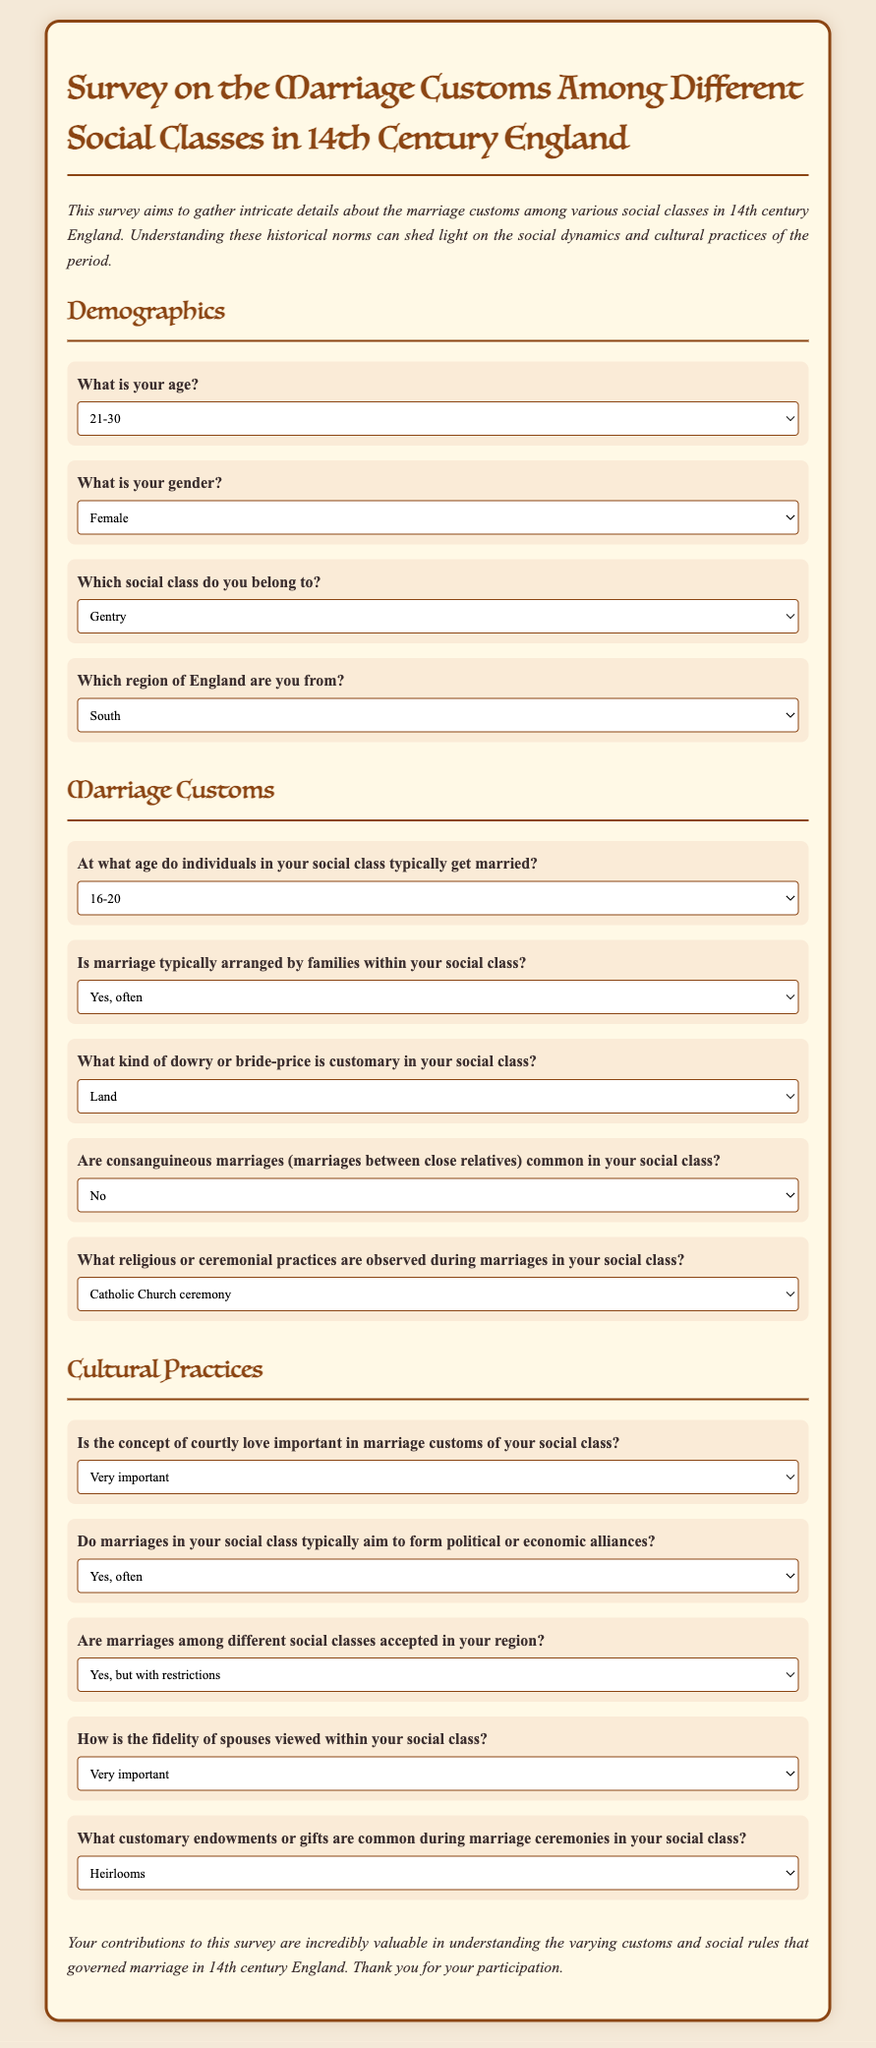What is the age range selected by the participant? The selected age range by the participant in the form is shown in the demographics section, specifically the option selected for age.
Answer: 21-30 What gender did the participant identify as? The participant's gender selection is found under the demographics section, precisely indicating their self-identified gender.
Answer: Female Which social class does the participant belong to? The participant's response on their social class is listed in the demographics section, reflecting their social standing.
Answer: Gentry What region of England is the participant from? The selected region by the participant is mentioned in the demographics section, showing the location of their residence.
Answer: South At what age do individuals in the participant's social class typically get married? The typical marriage age in the participant's social class is specified in the marriage customs section of the form.
Answer: 16-20 Is marriage typically arranged by families within the participant's social class? The participant's response about arranged marriages is noted in the marriage customs section, indicating how marriage is usually handled.
Answer: Yes, often What type of dowry is customary in the participant's social class? The customary dowry is specified in the marriage customs section, where the participant selects an option regarding this practice.
Answer: Land Are consanguineous marriages common in the participant's social class? The participant's answer regarding consanguineous marriages is found in the marriage customs section, indicating the prevalence of such marriages.
Answer: No How is the fidelity of spouses viewed within the participant's social class? The response regarding the importance of fidelity is stated in the cultural practices section of the survey form.
Answer: Very important Do marriages in the participant's social class typically aim to form political alliances? The participant's perspective on the purpose of marriages regarding political alliances is detailed in the cultural practices section.
Answer: Yes, often 